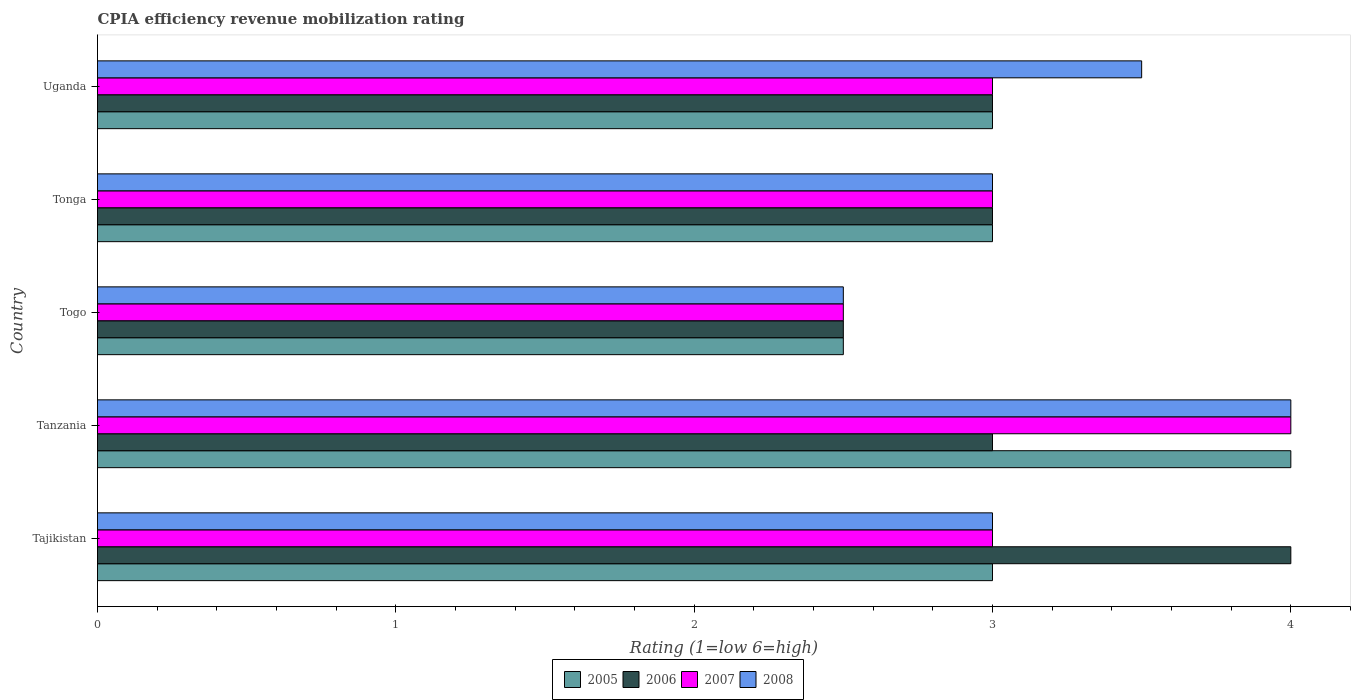How many different coloured bars are there?
Your response must be concise. 4. How many groups of bars are there?
Provide a short and direct response. 5. How many bars are there on the 5th tick from the bottom?
Ensure brevity in your answer.  4. What is the label of the 4th group of bars from the top?
Your response must be concise. Tanzania. In how many cases, is the number of bars for a given country not equal to the number of legend labels?
Your response must be concise. 0. What is the CPIA rating in 2007 in Uganda?
Give a very brief answer. 3. In which country was the CPIA rating in 2005 maximum?
Provide a succinct answer. Tanzania. In which country was the CPIA rating in 2008 minimum?
Ensure brevity in your answer.  Togo. What is the difference between the CPIA rating in 2008 in Tanzania and the CPIA rating in 2006 in Uganda?
Offer a very short reply. 1. What is the average CPIA rating in 2005 per country?
Your answer should be compact. 3.1. What is the difference between the CPIA rating in 2008 and CPIA rating in 2005 in Tanzania?
Ensure brevity in your answer.  0. In how many countries, is the CPIA rating in 2006 greater than 2.4 ?
Ensure brevity in your answer.  5. What is the ratio of the CPIA rating in 2006 in Tajikistan to that in Tonga?
Offer a very short reply. 1.33. Is the difference between the CPIA rating in 2008 in Tanzania and Tonga greater than the difference between the CPIA rating in 2005 in Tanzania and Tonga?
Provide a succinct answer. No. What is the difference between the highest and the second highest CPIA rating in 2005?
Ensure brevity in your answer.  1. What is the difference between the highest and the lowest CPIA rating in 2006?
Provide a short and direct response. 1.5. In how many countries, is the CPIA rating in 2005 greater than the average CPIA rating in 2005 taken over all countries?
Offer a very short reply. 1. Is the sum of the CPIA rating in 2006 in Tonga and Uganda greater than the maximum CPIA rating in 2008 across all countries?
Ensure brevity in your answer.  Yes. What does the 4th bar from the top in Tanzania represents?
Ensure brevity in your answer.  2005. What does the 3rd bar from the bottom in Uganda represents?
Offer a very short reply. 2007. Is it the case that in every country, the sum of the CPIA rating in 2008 and CPIA rating in 2005 is greater than the CPIA rating in 2006?
Give a very brief answer. Yes. Are the values on the major ticks of X-axis written in scientific E-notation?
Ensure brevity in your answer.  No. Does the graph contain any zero values?
Provide a succinct answer. No. How many legend labels are there?
Your answer should be very brief. 4. How are the legend labels stacked?
Give a very brief answer. Horizontal. What is the title of the graph?
Your response must be concise. CPIA efficiency revenue mobilization rating. What is the Rating (1=low 6=high) in 2006 in Tajikistan?
Ensure brevity in your answer.  4. What is the Rating (1=low 6=high) in 2007 in Tajikistan?
Your response must be concise. 3. What is the Rating (1=low 6=high) in 2008 in Tajikistan?
Your answer should be very brief. 3. What is the Rating (1=low 6=high) in 2006 in Tanzania?
Offer a terse response. 3. What is the Rating (1=low 6=high) of 2005 in Togo?
Offer a very short reply. 2.5. What is the Rating (1=low 6=high) of 2006 in Togo?
Your answer should be compact. 2.5. What is the Rating (1=low 6=high) of 2007 in Togo?
Give a very brief answer. 2.5. What is the Rating (1=low 6=high) in 2007 in Tonga?
Your answer should be very brief. 3. What is the Rating (1=low 6=high) of 2008 in Tonga?
Provide a succinct answer. 3. What is the Rating (1=low 6=high) in 2007 in Uganda?
Offer a terse response. 3. What is the Rating (1=low 6=high) of 2008 in Uganda?
Your answer should be very brief. 3.5. Across all countries, what is the maximum Rating (1=low 6=high) of 2006?
Keep it short and to the point. 4. Across all countries, what is the minimum Rating (1=low 6=high) in 2005?
Your answer should be very brief. 2.5. Across all countries, what is the minimum Rating (1=low 6=high) of 2007?
Keep it short and to the point. 2.5. Across all countries, what is the minimum Rating (1=low 6=high) of 2008?
Give a very brief answer. 2.5. What is the total Rating (1=low 6=high) in 2005 in the graph?
Ensure brevity in your answer.  15.5. What is the total Rating (1=low 6=high) in 2007 in the graph?
Give a very brief answer. 15.5. What is the total Rating (1=low 6=high) of 2008 in the graph?
Provide a short and direct response. 16. What is the difference between the Rating (1=low 6=high) in 2006 in Tajikistan and that in Tanzania?
Provide a succinct answer. 1. What is the difference between the Rating (1=low 6=high) of 2007 in Tajikistan and that in Tanzania?
Your answer should be very brief. -1. What is the difference between the Rating (1=low 6=high) of 2007 in Tajikistan and that in Togo?
Your answer should be very brief. 0.5. What is the difference between the Rating (1=low 6=high) of 2008 in Tajikistan and that in Togo?
Offer a terse response. 0.5. What is the difference between the Rating (1=low 6=high) in 2006 in Tanzania and that in Togo?
Offer a very short reply. 0.5. What is the difference between the Rating (1=low 6=high) of 2007 in Tanzania and that in Togo?
Your answer should be very brief. 1.5. What is the difference between the Rating (1=low 6=high) in 2005 in Tanzania and that in Tonga?
Your answer should be very brief. 1. What is the difference between the Rating (1=low 6=high) in 2008 in Tanzania and that in Tonga?
Make the answer very short. 1. What is the difference between the Rating (1=low 6=high) in 2007 in Tanzania and that in Uganda?
Provide a succinct answer. 1. What is the difference between the Rating (1=low 6=high) of 2008 in Tanzania and that in Uganda?
Provide a short and direct response. 0.5. What is the difference between the Rating (1=low 6=high) of 2006 in Togo and that in Tonga?
Give a very brief answer. -0.5. What is the difference between the Rating (1=low 6=high) in 2008 in Togo and that in Tonga?
Keep it short and to the point. -0.5. What is the difference between the Rating (1=low 6=high) in 2005 in Togo and that in Uganda?
Your answer should be very brief. -0.5. What is the difference between the Rating (1=low 6=high) of 2006 in Tonga and that in Uganda?
Offer a very short reply. 0. What is the difference between the Rating (1=low 6=high) in 2007 in Tonga and that in Uganda?
Give a very brief answer. 0. What is the difference between the Rating (1=low 6=high) of 2008 in Tonga and that in Uganda?
Offer a terse response. -0.5. What is the difference between the Rating (1=low 6=high) in 2005 in Tajikistan and the Rating (1=low 6=high) in 2006 in Tanzania?
Your response must be concise. 0. What is the difference between the Rating (1=low 6=high) of 2005 in Tajikistan and the Rating (1=low 6=high) of 2008 in Tanzania?
Make the answer very short. -1. What is the difference between the Rating (1=low 6=high) in 2006 in Tajikistan and the Rating (1=low 6=high) in 2007 in Tanzania?
Your answer should be very brief. 0. What is the difference between the Rating (1=low 6=high) of 2005 in Tajikistan and the Rating (1=low 6=high) of 2006 in Togo?
Ensure brevity in your answer.  0.5. What is the difference between the Rating (1=low 6=high) in 2005 in Tajikistan and the Rating (1=low 6=high) in 2007 in Togo?
Keep it short and to the point. 0.5. What is the difference between the Rating (1=low 6=high) in 2005 in Tajikistan and the Rating (1=low 6=high) in 2008 in Togo?
Offer a very short reply. 0.5. What is the difference between the Rating (1=low 6=high) in 2005 in Tajikistan and the Rating (1=low 6=high) in 2007 in Tonga?
Keep it short and to the point. 0. What is the difference between the Rating (1=low 6=high) of 2005 in Tajikistan and the Rating (1=low 6=high) of 2008 in Tonga?
Your answer should be very brief. 0. What is the difference between the Rating (1=low 6=high) in 2006 in Tajikistan and the Rating (1=low 6=high) in 2007 in Tonga?
Your answer should be very brief. 1. What is the difference between the Rating (1=low 6=high) in 2006 in Tajikistan and the Rating (1=low 6=high) in 2007 in Uganda?
Ensure brevity in your answer.  1. What is the difference between the Rating (1=low 6=high) of 2005 in Tanzania and the Rating (1=low 6=high) of 2006 in Togo?
Your answer should be very brief. 1.5. What is the difference between the Rating (1=low 6=high) in 2005 in Tanzania and the Rating (1=low 6=high) in 2007 in Togo?
Give a very brief answer. 1.5. What is the difference between the Rating (1=low 6=high) of 2005 in Tanzania and the Rating (1=low 6=high) of 2008 in Togo?
Give a very brief answer. 1.5. What is the difference between the Rating (1=low 6=high) in 2006 in Tanzania and the Rating (1=low 6=high) in 2008 in Togo?
Provide a short and direct response. 0.5. What is the difference between the Rating (1=low 6=high) in 2005 in Tanzania and the Rating (1=low 6=high) in 2007 in Tonga?
Offer a terse response. 1. What is the difference between the Rating (1=low 6=high) in 2005 in Tanzania and the Rating (1=low 6=high) in 2008 in Tonga?
Your answer should be compact. 1. What is the difference between the Rating (1=low 6=high) of 2007 in Tanzania and the Rating (1=low 6=high) of 2008 in Tonga?
Make the answer very short. 1. What is the difference between the Rating (1=low 6=high) in 2006 in Tanzania and the Rating (1=low 6=high) in 2007 in Uganda?
Provide a succinct answer. 0. What is the difference between the Rating (1=low 6=high) in 2006 in Togo and the Rating (1=low 6=high) in 2008 in Tonga?
Offer a very short reply. -0.5. What is the difference between the Rating (1=low 6=high) of 2007 in Togo and the Rating (1=low 6=high) of 2008 in Tonga?
Offer a very short reply. -0.5. What is the difference between the Rating (1=low 6=high) in 2005 in Togo and the Rating (1=low 6=high) in 2007 in Uganda?
Offer a terse response. -0.5. What is the difference between the Rating (1=low 6=high) in 2005 in Togo and the Rating (1=low 6=high) in 2008 in Uganda?
Your answer should be very brief. -1. What is the difference between the Rating (1=low 6=high) in 2006 in Togo and the Rating (1=low 6=high) in 2007 in Uganda?
Ensure brevity in your answer.  -0.5. What is the difference between the Rating (1=low 6=high) of 2005 in Tonga and the Rating (1=low 6=high) of 2006 in Uganda?
Provide a succinct answer. 0. What is the difference between the Rating (1=low 6=high) in 2006 in Tonga and the Rating (1=low 6=high) in 2007 in Uganda?
Your answer should be very brief. 0. What is the difference between the Rating (1=low 6=high) of 2006 in Tonga and the Rating (1=low 6=high) of 2008 in Uganda?
Ensure brevity in your answer.  -0.5. What is the average Rating (1=low 6=high) in 2005 per country?
Provide a short and direct response. 3.1. What is the average Rating (1=low 6=high) of 2007 per country?
Ensure brevity in your answer.  3.1. What is the average Rating (1=low 6=high) of 2008 per country?
Offer a very short reply. 3.2. What is the difference between the Rating (1=low 6=high) of 2005 and Rating (1=low 6=high) of 2007 in Tajikistan?
Your response must be concise. 0. What is the difference between the Rating (1=low 6=high) of 2005 and Rating (1=low 6=high) of 2008 in Tajikistan?
Provide a short and direct response. 0. What is the difference between the Rating (1=low 6=high) of 2005 and Rating (1=low 6=high) of 2008 in Tanzania?
Ensure brevity in your answer.  0. What is the difference between the Rating (1=low 6=high) in 2006 and Rating (1=low 6=high) in 2008 in Tanzania?
Keep it short and to the point. -1. What is the difference between the Rating (1=low 6=high) of 2007 and Rating (1=low 6=high) of 2008 in Tanzania?
Provide a short and direct response. 0. What is the difference between the Rating (1=low 6=high) in 2006 and Rating (1=low 6=high) in 2007 in Togo?
Give a very brief answer. 0. What is the difference between the Rating (1=low 6=high) of 2006 and Rating (1=low 6=high) of 2008 in Togo?
Keep it short and to the point. 0. What is the difference between the Rating (1=low 6=high) of 2007 and Rating (1=low 6=high) of 2008 in Togo?
Provide a short and direct response. 0. What is the difference between the Rating (1=low 6=high) of 2005 and Rating (1=low 6=high) of 2007 in Tonga?
Your answer should be very brief. 0. What is the difference between the Rating (1=low 6=high) in 2006 and Rating (1=low 6=high) in 2007 in Tonga?
Your response must be concise. 0. What is the difference between the Rating (1=low 6=high) in 2007 and Rating (1=low 6=high) in 2008 in Tonga?
Keep it short and to the point. 0. What is the difference between the Rating (1=low 6=high) in 2005 and Rating (1=low 6=high) in 2007 in Uganda?
Your response must be concise. 0. What is the difference between the Rating (1=low 6=high) in 2005 and Rating (1=low 6=high) in 2008 in Uganda?
Keep it short and to the point. -0.5. What is the difference between the Rating (1=low 6=high) of 2006 and Rating (1=low 6=high) of 2007 in Uganda?
Your answer should be compact. 0. What is the difference between the Rating (1=low 6=high) of 2007 and Rating (1=low 6=high) of 2008 in Uganda?
Keep it short and to the point. -0.5. What is the ratio of the Rating (1=low 6=high) of 2005 in Tajikistan to that in Tanzania?
Give a very brief answer. 0.75. What is the ratio of the Rating (1=low 6=high) of 2006 in Tajikistan to that in Tanzania?
Give a very brief answer. 1.33. What is the ratio of the Rating (1=low 6=high) in 2008 in Tajikistan to that in Tanzania?
Ensure brevity in your answer.  0.75. What is the ratio of the Rating (1=low 6=high) in 2005 in Tajikistan to that in Togo?
Ensure brevity in your answer.  1.2. What is the ratio of the Rating (1=low 6=high) of 2008 in Tajikistan to that in Togo?
Offer a very short reply. 1.2. What is the ratio of the Rating (1=low 6=high) of 2006 in Tajikistan to that in Tonga?
Your answer should be compact. 1.33. What is the ratio of the Rating (1=low 6=high) of 2006 in Tajikistan to that in Uganda?
Offer a terse response. 1.33. What is the ratio of the Rating (1=low 6=high) in 2008 in Tanzania to that in Togo?
Ensure brevity in your answer.  1.6. What is the ratio of the Rating (1=low 6=high) in 2008 in Tanzania to that in Tonga?
Make the answer very short. 1.33. What is the ratio of the Rating (1=low 6=high) in 2005 in Tanzania to that in Uganda?
Give a very brief answer. 1.33. What is the ratio of the Rating (1=low 6=high) of 2006 in Tanzania to that in Uganda?
Offer a very short reply. 1. What is the ratio of the Rating (1=low 6=high) in 2007 in Togo to that in Tonga?
Your response must be concise. 0.83. What is the ratio of the Rating (1=low 6=high) in 2008 in Togo to that in Tonga?
Provide a short and direct response. 0.83. What is the ratio of the Rating (1=low 6=high) in 2007 in Togo to that in Uganda?
Provide a short and direct response. 0.83. What is the ratio of the Rating (1=low 6=high) in 2007 in Tonga to that in Uganda?
Your response must be concise. 1. What is the difference between the highest and the second highest Rating (1=low 6=high) in 2006?
Your response must be concise. 1. What is the difference between the highest and the second highest Rating (1=low 6=high) in 2007?
Your answer should be compact. 1. What is the difference between the highest and the second highest Rating (1=low 6=high) in 2008?
Ensure brevity in your answer.  0.5. What is the difference between the highest and the lowest Rating (1=low 6=high) in 2008?
Provide a succinct answer. 1.5. 